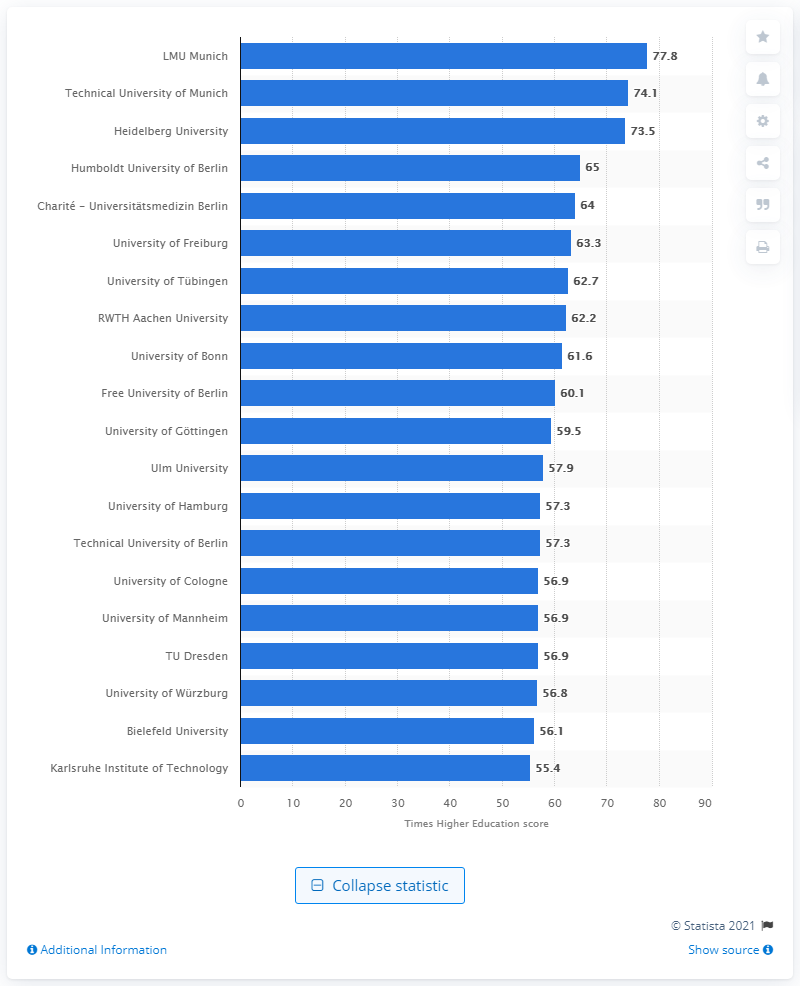Draw attention to some important aspects in this diagram. Heidelberg University was ranked third in Germany in 2020. In the rankings of German universities, the Technical University of Munich was the second highest ranked university. 